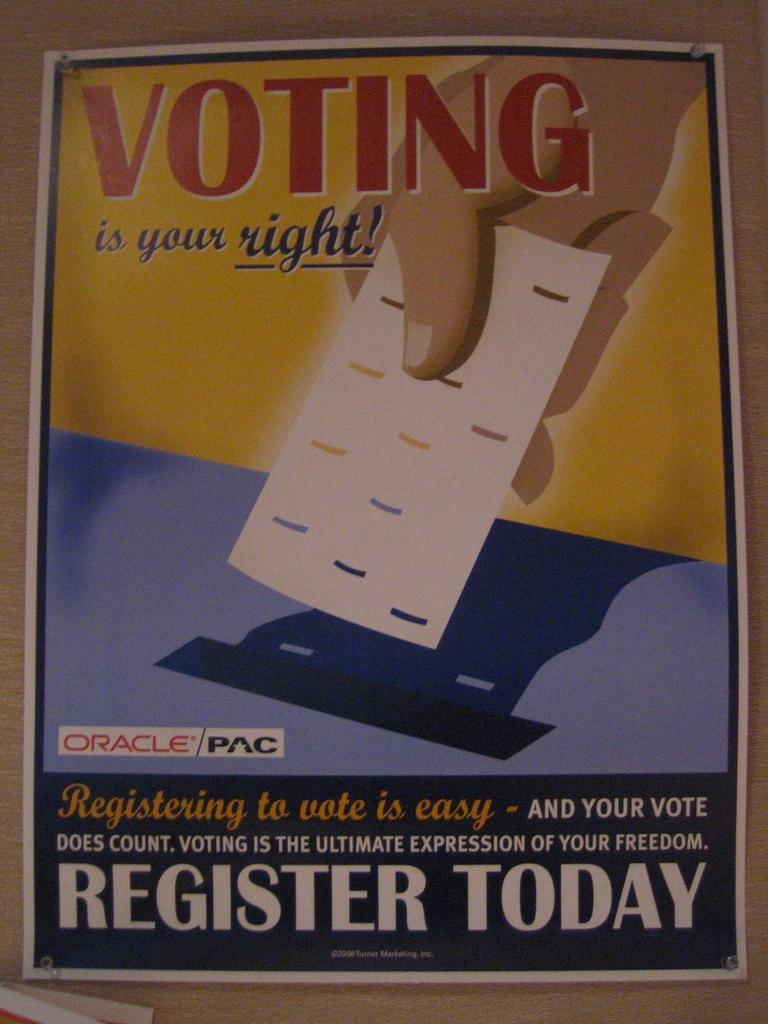<image>
Provide a brief description of the given image. a poster for Voting is your Right sponsored by Oracle/PAC 